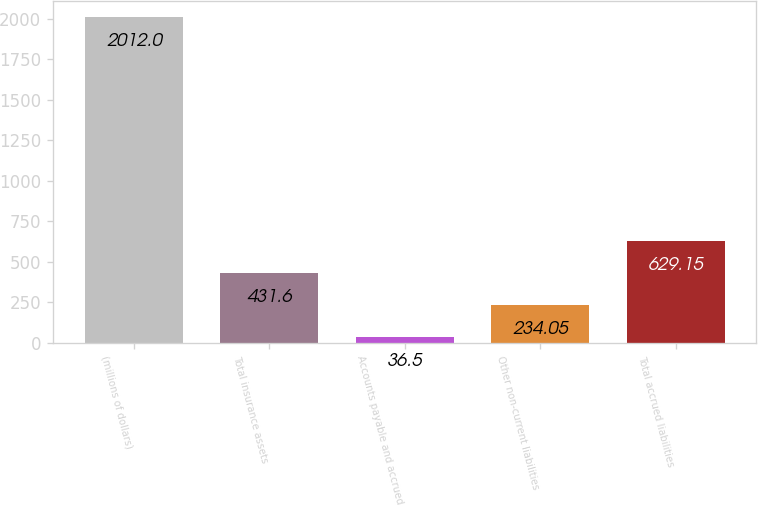Convert chart. <chart><loc_0><loc_0><loc_500><loc_500><bar_chart><fcel>(millions of dollars)<fcel>Total insurance assets<fcel>Accounts payable and accrued<fcel>Other non-current liabilities<fcel>Total accrued liabilities<nl><fcel>2012<fcel>431.6<fcel>36.5<fcel>234.05<fcel>629.15<nl></chart> 